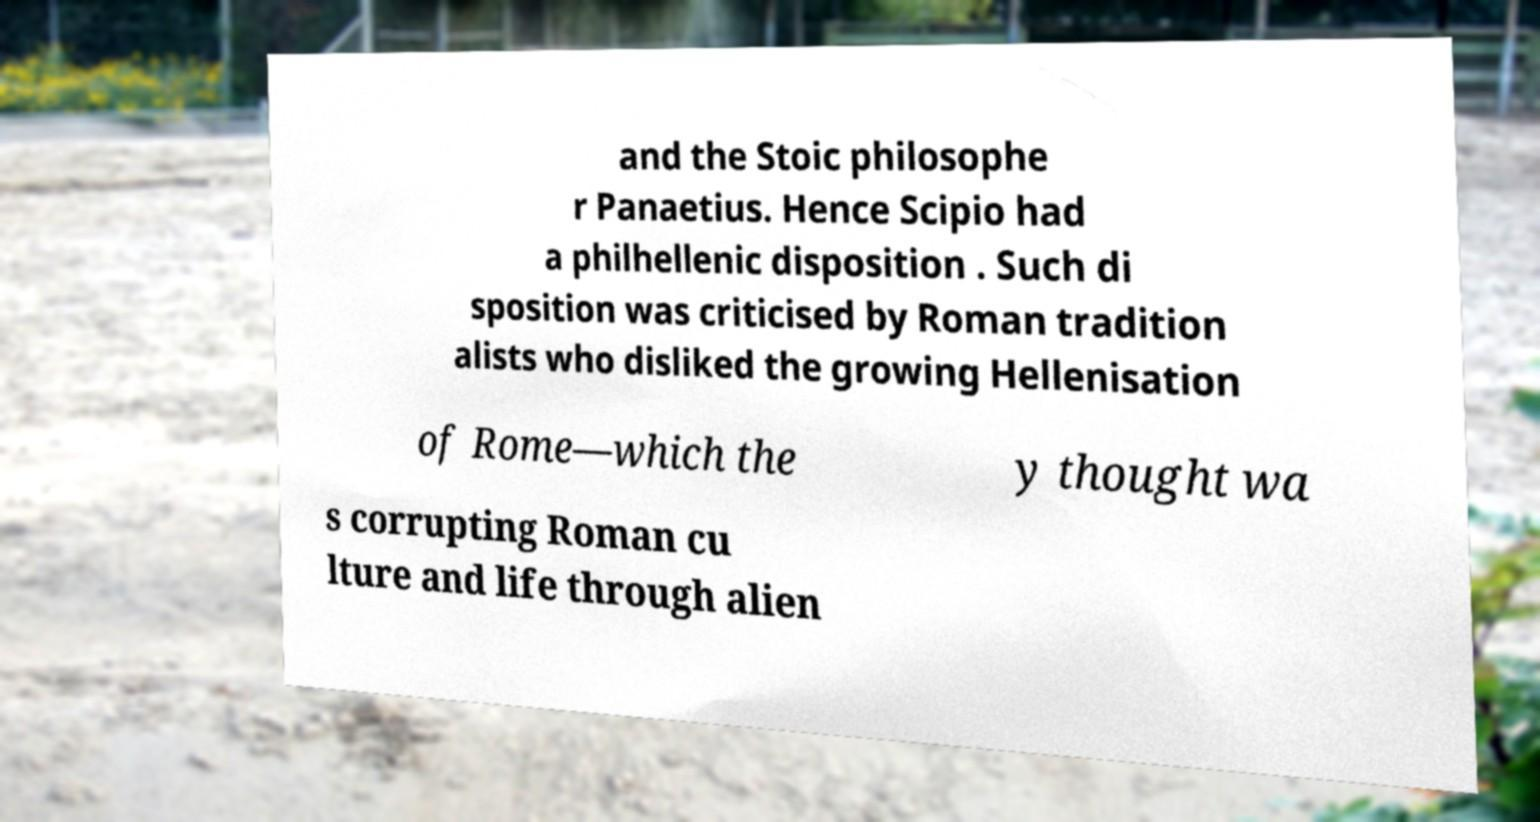There's text embedded in this image that I need extracted. Can you transcribe it verbatim? and the Stoic philosophe r Panaetius. Hence Scipio had a philhellenic disposition . Such di sposition was criticised by Roman tradition alists who disliked the growing Hellenisation of Rome—which the y thought wa s corrupting Roman cu lture and life through alien 